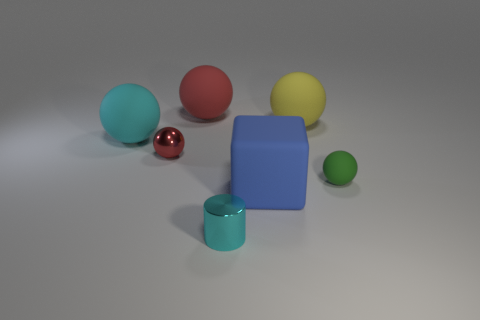Which object stands out the most to you? The red sphere stands out due to its vibrant color and the contrast it creates with the more subdued shades in the image. 